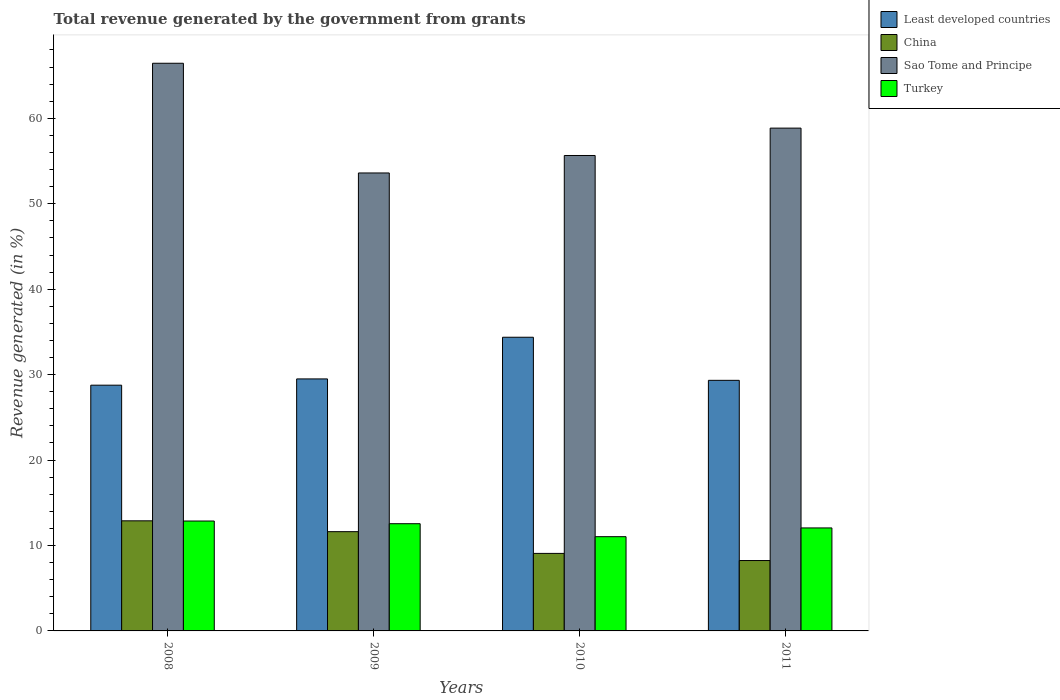How many different coloured bars are there?
Your answer should be compact. 4. How many groups of bars are there?
Provide a succinct answer. 4. Are the number of bars on each tick of the X-axis equal?
Make the answer very short. Yes. How many bars are there on the 4th tick from the left?
Offer a very short reply. 4. What is the label of the 4th group of bars from the left?
Your response must be concise. 2011. In how many cases, is the number of bars for a given year not equal to the number of legend labels?
Ensure brevity in your answer.  0. What is the total revenue generated in Sao Tome and Principe in 2011?
Ensure brevity in your answer.  58.85. Across all years, what is the maximum total revenue generated in Sao Tome and Principe?
Your answer should be very brief. 66.45. Across all years, what is the minimum total revenue generated in China?
Offer a very short reply. 8.24. In which year was the total revenue generated in China maximum?
Keep it short and to the point. 2008. In which year was the total revenue generated in Turkey minimum?
Offer a terse response. 2010. What is the total total revenue generated in Turkey in the graph?
Provide a short and direct response. 48.5. What is the difference between the total revenue generated in China in 2008 and that in 2010?
Ensure brevity in your answer.  3.81. What is the difference between the total revenue generated in China in 2010 and the total revenue generated in Least developed countries in 2009?
Offer a terse response. -20.42. What is the average total revenue generated in China per year?
Your answer should be very brief. 10.45. In the year 2008, what is the difference between the total revenue generated in Turkey and total revenue generated in Sao Tome and Principe?
Your response must be concise. -53.58. What is the ratio of the total revenue generated in Turkey in 2008 to that in 2011?
Your response must be concise. 1.07. Is the difference between the total revenue generated in Turkey in 2008 and 2009 greater than the difference between the total revenue generated in Sao Tome and Principe in 2008 and 2009?
Your answer should be compact. No. What is the difference between the highest and the second highest total revenue generated in Turkey?
Offer a terse response. 0.32. What is the difference between the highest and the lowest total revenue generated in Least developed countries?
Offer a terse response. 5.61. In how many years, is the total revenue generated in China greater than the average total revenue generated in China taken over all years?
Offer a very short reply. 2. What does the 1st bar from the left in 2011 represents?
Keep it short and to the point. Least developed countries. What does the 2nd bar from the right in 2011 represents?
Provide a short and direct response. Sao Tome and Principe. Is it the case that in every year, the sum of the total revenue generated in China and total revenue generated in Least developed countries is greater than the total revenue generated in Turkey?
Give a very brief answer. Yes. How many bars are there?
Ensure brevity in your answer.  16. Does the graph contain any zero values?
Offer a terse response. No. Where does the legend appear in the graph?
Your answer should be compact. Top right. How are the legend labels stacked?
Provide a succinct answer. Vertical. What is the title of the graph?
Provide a succinct answer. Total revenue generated by the government from grants. What is the label or title of the X-axis?
Give a very brief answer. Years. What is the label or title of the Y-axis?
Offer a terse response. Revenue generated (in %). What is the Revenue generated (in %) of Least developed countries in 2008?
Provide a short and direct response. 28.76. What is the Revenue generated (in %) in China in 2008?
Offer a very short reply. 12.89. What is the Revenue generated (in %) of Sao Tome and Principe in 2008?
Your answer should be very brief. 66.45. What is the Revenue generated (in %) of Turkey in 2008?
Offer a terse response. 12.86. What is the Revenue generated (in %) in Least developed countries in 2009?
Provide a succinct answer. 29.5. What is the Revenue generated (in %) of China in 2009?
Your answer should be compact. 11.62. What is the Revenue generated (in %) in Sao Tome and Principe in 2009?
Provide a succinct answer. 53.6. What is the Revenue generated (in %) of Turkey in 2009?
Provide a succinct answer. 12.55. What is the Revenue generated (in %) of Least developed countries in 2010?
Your answer should be very brief. 34.38. What is the Revenue generated (in %) in China in 2010?
Offer a terse response. 9.07. What is the Revenue generated (in %) in Sao Tome and Principe in 2010?
Offer a terse response. 55.65. What is the Revenue generated (in %) in Turkey in 2010?
Make the answer very short. 11.03. What is the Revenue generated (in %) in Least developed countries in 2011?
Your response must be concise. 29.33. What is the Revenue generated (in %) of China in 2011?
Keep it short and to the point. 8.24. What is the Revenue generated (in %) in Sao Tome and Principe in 2011?
Make the answer very short. 58.85. What is the Revenue generated (in %) of Turkey in 2011?
Make the answer very short. 12.05. Across all years, what is the maximum Revenue generated (in %) of Least developed countries?
Your answer should be very brief. 34.38. Across all years, what is the maximum Revenue generated (in %) of China?
Your answer should be very brief. 12.89. Across all years, what is the maximum Revenue generated (in %) of Sao Tome and Principe?
Offer a very short reply. 66.45. Across all years, what is the maximum Revenue generated (in %) of Turkey?
Give a very brief answer. 12.86. Across all years, what is the minimum Revenue generated (in %) in Least developed countries?
Offer a terse response. 28.76. Across all years, what is the minimum Revenue generated (in %) in China?
Your answer should be very brief. 8.24. Across all years, what is the minimum Revenue generated (in %) of Sao Tome and Principe?
Offer a very short reply. 53.6. Across all years, what is the minimum Revenue generated (in %) of Turkey?
Make the answer very short. 11.03. What is the total Revenue generated (in %) in Least developed countries in the graph?
Your answer should be compact. 121.97. What is the total Revenue generated (in %) of China in the graph?
Your response must be concise. 41.82. What is the total Revenue generated (in %) in Sao Tome and Principe in the graph?
Provide a short and direct response. 234.56. What is the total Revenue generated (in %) of Turkey in the graph?
Offer a very short reply. 48.5. What is the difference between the Revenue generated (in %) of Least developed countries in 2008 and that in 2009?
Provide a succinct answer. -0.73. What is the difference between the Revenue generated (in %) of China in 2008 and that in 2009?
Make the answer very short. 1.27. What is the difference between the Revenue generated (in %) in Sao Tome and Principe in 2008 and that in 2009?
Keep it short and to the point. 12.84. What is the difference between the Revenue generated (in %) in Turkey in 2008 and that in 2009?
Your answer should be compact. 0.32. What is the difference between the Revenue generated (in %) in Least developed countries in 2008 and that in 2010?
Your response must be concise. -5.61. What is the difference between the Revenue generated (in %) in China in 2008 and that in 2010?
Your answer should be compact. 3.81. What is the difference between the Revenue generated (in %) of Sao Tome and Principe in 2008 and that in 2010?
Ensure brevity in your answer.  10.8. What is the difference between the Revenue generated (in %) in Turkey in 2008 and that in 2010?
Your answer should be compact. 1.83. What is the difference between the Revenue generated (in %) in Least developed countries in 2008 and that in 2011?
Provide a succinct answer. -0.57. What is the difference between the Revenue generated (in %) of China in 2008 and that in 2011?
Keep it short and to the point. 4.65. What is the difference between the Revenue generated (in %) in Sao Tome and Principe in 2008 and that in 2011?
Make the answer very short. 7.59. What is the difference between the Revenue generated (in %) of Turkey in 2008 and that in 2011?
Make the answer very short. 0.81. What is the difference between the Revenue generated (in %) in Least developed countries in 2009 and that in 2010?
Ensure brevity in your answer.  -4.88. What is the difference between the Revenue generated (in %) of China in 2009 and that in 2010?
Provide a succinct answer. 2.54. What is the difference between the Revenue generated (in %) in Sao Tome and Principe in 2009 and that in 2010?
Ensure brevity in your answer.  -2.04. What is the difference between the Revenue generated (in %) of Turkey in 2009 and that in 2010?
Provide a short and direct response. 1.52. What is the difference between the Revenue generated (in %) of Least developed countries in 2009 and that in 2011?
Provide a succinct answer. 0.17. What is the difference between the Revenue generated (in %) in China in 2009 and that in 2011?
Ensure brevity in your answer.  3.38. What is the difference between the Revenue generated (in %) of Sao Tome and Principe in 2009 and that in 2011?
Your response must be concise. -5.25. What is the difference between the Revenue generated (in %) of Turkey in 2009 and that in 2011?
Ensure brevity in your answer.  0.49. What is the difference between the Revenue generated (in %) of Least developed countries in 2010 and that in 2011?
Offer a very short reply. 5.04. What is the difference between the Revenue generated (in %) in China in 2010 and that in 2011?
Your answer should be compact. 0.83. What is the difference between the Revenue generated (in %) of Sao Tome and Principe in 2010 and that in 2011?
Offer a very short reply. -3.21. What is the difference between the Revenue generated (in %) of Turkey in 2010 and that in 2011?
Provide a succinct answer. -1.02. What is the difference between the Revenue generated (in %) in Least developed countries in 2008 and the Revenue generated (in %) in China in 2009?
Your answer should be very brief. 17.15. What is the difference between the Revenue generated (in %) in Least developed countries in 2008 and the Revenue generated (in %) in Sao Tome and Principe in 2009?
Your response must be concise. -24.84. What is the difference between the Revenue generated (in %) of Least developed countries in 2008 and the Revenue generated (in %) of Turkey in 2009?
Your answer should be compact. 16.22. What is the difference between the Revenue generated (in %) of China in 2008 and the Revenue generated (in %) of Sao Tome and Principe in 2009?
Your answer should be compact. -40.72. What is the difference between the Revenue generated (in %) of China in 2008 and the Revenue generated (in %) of Turkey in 2009?
Provide a short and direct response. 0.34. What is the difference between the Revenue generated (in %) of Sao Tome and Principe in 2008 and the Revenue generated (in %) of Turkey in 2009?
Keep it short and to the point. 53.9. What is the difference between the Revenue generated (in %) in Least developed countries in 2008 and the Revenue generated (in %) in China in 2010?
Make the answer very short. 19.69. What is the difference between the Revenue generated (in %) in Least developed countries in 2008 and the Revenue generated (in %) in Sao Tome and Principe in 2010?
Offer a terse response. -26.88. What is the difference between the Revenue generated (in %) in Least developed countries in 2008 and the Revenue generated (in %) in Turkey in 2010?
Keep it short and to the point. 17.73. What is the difference between the Revenue generated (in %) in China in 2008 and the Revenue generated (in %) in Sao Tome and Principe in 2010?
Provide a succinct answer. -42.76. What is the difference between the Revenue generated (in %) of China in 2008 and the Revenue generated (in %) of Turkey in 2010?
Offer a terse response. 1.86. What is the difference between the Revenue generated (in %) in Sao Tome and Principe in 2008 and the Revenue generated (in %) in Turkey in 2010?
Your answer should be compact. 55.41. What is the difference between the Revenue generated (in %) in Least developed countries in 2008 and the Revenue generated (in %) in China in 2011?
Give a very brief answer. 20.53. What is the difference between the Revenue generated (in %) in Least developed countries in 2008 and the Revenue generated (in %) in Sao Tome and Principe in 2011?
Provide a short and direct response. -30.09. What is the difference between the Revenue generated (in %) of Least developed countries in 2008 and the Revenue generated (in %) of Turkey in 2011?
Make the answer very short. 16.71. What is the difference between the Revenue generated (in %) of China in 2008 and the Revenue generated (in %) of Sao Tome and Principe in 2011?
Your answer should be very brief. -45.97. What is the difference between the Revenue generated (in %) of China in 2008 and the Revenue generated (in %) of Turkey in 2011?
Offer a terse response. 0.83. What is the difference between the Revenue generated (in %) in Sao Tome and Principe in 2008 and the Revenue generated (in %) in Turkey in 2011?
Offer a terse response. 54.39. What is the difference between the Revenue generated (in %) of Least developed countries in 2009 and the Revenue generated (in %) of China in 2010?
Your response must be concise. 20.42. What is the difference between the Revenue generated (in %) of Least developed countries in 2009 and the Revenue generated (in %) of Sao Tome and Principe in 2010?
Your answer should be very brief. -26.15. What is the difference between the Revenue generated (in %) of Least developed countries in 2009 and the Revenue generated (in %) of Turkey in 2010?
Your response must be concise. 18.47. What is the difference between the Revenue generated (in %) in China in 2009 and the Revenue generated (in %) in Sao Tome and Principe in 2010?
Your answer should be compact. -44.03. What is the difference between the Revenue generated (in %) in China in 2009 and the Revenue generated (in %) in Turkey in 2010?
Ensure brevity in your answer.  0.59. What is the difference between the Revenue generated (in %) in Sao Tome and Principe in 2009 and the Revenue generated (in %) in Turkey in 2010?
Keep it short and to the point. 42.57. What is the difference between the Revenue generated (in %) of Least developed countries in 2009 and the Revenue generated (in %) of China in 2011?
Offer a terse response. 21.26. What is the difference between the Revenue generated (in %) in Least developed countries in 2009 and the Revenue generated (in %) in Sao Tome and Principe in 2011?
Offer a terse response. -29.36. What is the difference between the Revenue generated (in %) of Least developed countries in 2009 and the Revenue generated (in %) of Turkey in 2011?
Provide a succinct answer. 17.44. What is the difference between the Revenue generated (in %) of China in 2009 and the Revenue generated (in %) of Sao Tome and Principe in 2011?
Keep it short and to the point. -47.24. What is the difference between the Revenue generated (in %) of China in 2009 and the Revenue generated (in %) of Turkey in 2011?
Keep it short and to the point. -0.44. What is the difference between the Revenue generated (in %) of Sao Tome and Principe in 2009 and the Revenue generated (in %) of Turkey in 2011?
Provide a succinct answer. 41.55. What is the difference between the Revenue generated (in %) of Least developed countries in 2010 and the Revenue generated (in %) of China in 2011?
Keep it short and to the point. 26.14. What is the difference between the Revenue generated (in %) of Least developed countries in 2010 and the Revenue generated (in %) of Sao Tome and Principe in 2011?
Give a very brief answer. -24.48. What is the difference between the Revenue generated (in %) in Least developed countries in 2010 and the Revenue generated (in %) in Turkey in 2011?
Offer a terse response. 22.32. What is the difference between the Revenue generated (in %) in China in 2010 and the Revenue generated (in %) in Sao Tome and Principe in 2011?
Your response must be concise. -49.78. What is the difference between the Revenue generated (in %) of China in 2010 and the Revenue generated (in %) of Turkey in 2011?
Your answer should be compact. -2.98. What is the difference between the Revenue generated (in %) of Sao Tome and Principe in 2010 and the Revenue generated (in %) of Turkey in 2011?
Give a very brief answer. 43.59. What is the average Revenue generated (in %) of Least developed countries per year?
Keep it short and to the point. 30.49. What is the average Revenue generated (in %) in China per year?
Keep it short and to the point. 10.45. What is the average Revenue generated (in %) of Sao Tome and Principe per year?
Your answer should be very brief. 58.64. What is the average Revenue generated (in %) of Turkey per year?
Offer a terse response. 12.12. In the year 2008, what is the difference between the Revenue generated (in %) in Least developed countries and Revenue generated (in %) in China?
Give a very brief answer. 15.88. In the year 2008, what is the difference between the Revenue generated (in %) in Least developed countries and Revenue generated (in %) in Sao Tome and Principe?
Provide a short and direct response. -37.68. In the year 2008, what is the difference between the Revenue generated (in %) in Least developed countries and Revenue generated (in %) in Turkey?
Your response must be concise. 15.9. In the year 2008, what is the difference between the Revenue generated (in %) of China and Revenue generated (in %) of Sao Tome and Principe?
Keep it short and to the point. -53.56. In the year 2008, what is the difference between the Revenue generated (in %) in China and Revenue generated (in %) in Turkey?
Keep it short and to the point. 0.02. In the year 2008, what is the difference between the Revenue generated (in %) of Sao Tome and Principe and Revenue generated (in %) of Turkey?
Give a very brief answer. 53.58. In the year 2009, what is the difference between the Revenue generated (in %) in Least developed countries and Revenue generated (in %) in China?
Ensure brevity in your answer.  17.88. In the year 2009, what is the difference between the Revenue generated (in %) of Least developed countries and Revenue generated (in %) of Sao Tome and Principe?
Keep it short and to the point. -24.11. In the year 2009, what is the difference between the Revenue generated (in %) of Least developed countries and Revenue generated (in %) of Turkey?
Your response must be concise. 16.95. In the year 2009, what is the difference between the Revenue generated (in %) in China and Revenue generated (in %) in Sao Tome and Principe?
Keep it short and to the point. -41.99. In the year 2009, what is the difference between the Revenue generated (in %) in China and Revenue generated (in %) in Turkey?
Ensure brevity in your answer.  -0.93. In the year 2009, what is the difference between the Revenue generated (in %) of Sao Tome and Principe and Revenue generated (in %) of Turkey?
Offer a terse response. 41.06. In the year 2010, what is the difference between the Revenue generated (in %) of Least developed countries and Revenue generated (in %) of China?
Give a very brief answer. 25.3. In the year 2010, what is the difference between the Revenue generated (in %) of Least developed countries and Revenue generated (in %) of Sao Tome and Principe?
Provide a succinct answer. -21.27. In the year 2010, what is the difference between the Revenue generated (in %) of Least developed countries and Revenue generated (in %) of Turkey?
Provide a succinct answer. 23.34. In the year 2010, what is the difference between the Revenue generated (in %) in China and Revenue generated (in %) in Sao Tome and Principe?
Your answer should be very brief. -46.58. In the year 2010, what is the difference between the Revenue generated (in %) in China and Revenue generated (in %) in Turkey?
Provide a succinct answer. -1.96. In the year 2010, what is the difference between the Revenue generated (in %) of Sao Tome and Principe and Revenue generated (in %) of Turkey?
Offer a very short reply. 44.62. In the year 2011, what is the difference between the Revenue generated (in %) in Least developed countries and Revenue generated (in %) in China?
Offer a terse response. 21.09. In the year 2011, what is the difference between the Revenue generated (in %) of Least developed countries and Revenue generated (in %) of Sao Tome and Principe?
Ensure brevity in your answer.  -29.52. In the year 2011, what is the difference between the Revenue generated (in %) in Least developed countries and Revenue generated (in %) in Turkey?
Your response must be concise. 17.28. In the year 2011, what is the difference between the Revenue generated (in %) of China and Revenue generated (in %) of Sao Tome and Principe?
Your answer should be compact. -50.62. In the year 2011, what is the difference between the Revenue generated (in %) in China and Revenue generated (in %) in Turkey?
Your answer should be compact. -3.82. In the year 2011, what is the difference between the Revenue generated (in %) in Sao Tome and Principe and Revenue generated (in %) in Turkey?
Offer a very short reply. 46.8. What is the ratio of the Revenue generated (in %) in Least developed countries in 2008 to that in 2009?
Offer a terse response. 0.98. What is the ratio of the Revenue generated (in %) of China in 2008 to that in 2009?
Your answer should be compact. 1.11. What is the ratio of the Revenue generated (in %) in Sao Tome and Principe in 2008 to that in 2009?
Provide a succinct answer. 1.24. What is the ratio of the Revenue generated (in %) of Turkey in 2008 to that in 2009?
Your answer should be very brief. 1.03. What is the ratio of the Revenue generated (in %) of Least developed countries in 2008 to that in 2010?
Make the answer very short. 0.84. What is the ratio of the Revenue generated (in %) in China in 2008 to that in 2010?
Provide a short and direct response. 1.42. What is the ratio of the Revenue generated (in %) in Sao Tome and Principe in 2008 to that in 2010?
Your answer should be very brief. 1.19. What is the ratio of the Revenue generated (in %) in Turkey in 2008 to that in 2010?
Give a very brief answer. 1.17. What is the ratio of the Revenue generated (in %) of Least developed countries in 2008 to that in 2011?
Give a very brief answer. 0.98. What is the ratio of the Revenue generated (in %) in China in 2008 to that in 2011?
Give a very brief answer. 1.56. What is the ratio of the Revenue generated (in %) of Sao Tome and Principe in 2008 to that in 2011?
Ensure brevity in your answer.  1.13. What is the ratio of the Revenue generated (in %) of Turkey in 2008 to that in 2011?
Your response must be concise. 1.07. What is the ratio of the Revenue generated (in %) of Least developed countries in 2009 to that in 2010?
Provide a succinct answer. 0.86. What is the ratio of the Revenue generated (in %) of China in 2009 to that in 2010?
Give a very brief answer. 1.28. What is the ratio of the Revenue generated (in %) of Sao Tome and Principe in 2009 to that in 2010?
Keep it short and to the point. 0.96. What is the ratio of the Revenue generated (in %) in Turkey in 2009 to that in 2010?
Provide a short and direct response. 1.14. What is the ratio of the Revenue generated (in %) in China in 2009 to that in 2011?
Offer a very short reply. 1.41. What is the ratio of the Revenue generated (in %) of Sao Tome and Principe in 2009 to that in 2011?
Your answer should be very brief. 0.91. What is the ratio of the Revenue generated (in %) in Turkey in 2009 to that in 2011?
Offer a terse response. 1.04. What is the ratio of the Revenue generated (in %) of Least developed countries in 2010 to that in 2011?
Your answer should be very brief. 1.17. What is the ratio of the Revenue generated (in %) in China in 2010 to that in 2011?
Give a very brief answer. 1.1. What is the ratio of the Revenue generated (in %) in Sao Tome and Principe in 2010 to that in 2011?
Ensure brevity in your answer.  0.95. What is the ratio of the Revenue generated (in %) of Turkey in 2010 to that in 2011?
Make the answer very short. 0.92. What is the difference between the highest and the second highest Revenue generated (in %) in Least developed countries?
Your response must be concise. 4.88. What is the difference between the highest and the second highest Revenue generated (in %) of China?
Keep it short and to the point. 1.27. What is the difference between the highest and the second highest Revenue generated (in %) in Sao Tome and Principe?
Offer a very short reply. 7.59. What is the difference between the highest and the second highest Revenue generated (in %) in Turkey?
Offer a very short reply. 0.32. What is the difference between the highest and the lowest Revenue generated (in %) in Least developed countries?
Offer a very short reply. 5.61. What is the difference between the highest and the lowest Revenue generated (in %) of China?
Offer a very short reply. 4.65. What is the difference between the highest and the lowest Revenue generated (in %) in Sao Tome and Principe?
Your response must be concise. 12.84. What is the difference between the highest and the lowest Revenue generated (in %) in Turkey?
Your answer should be very brief. 1.83. 